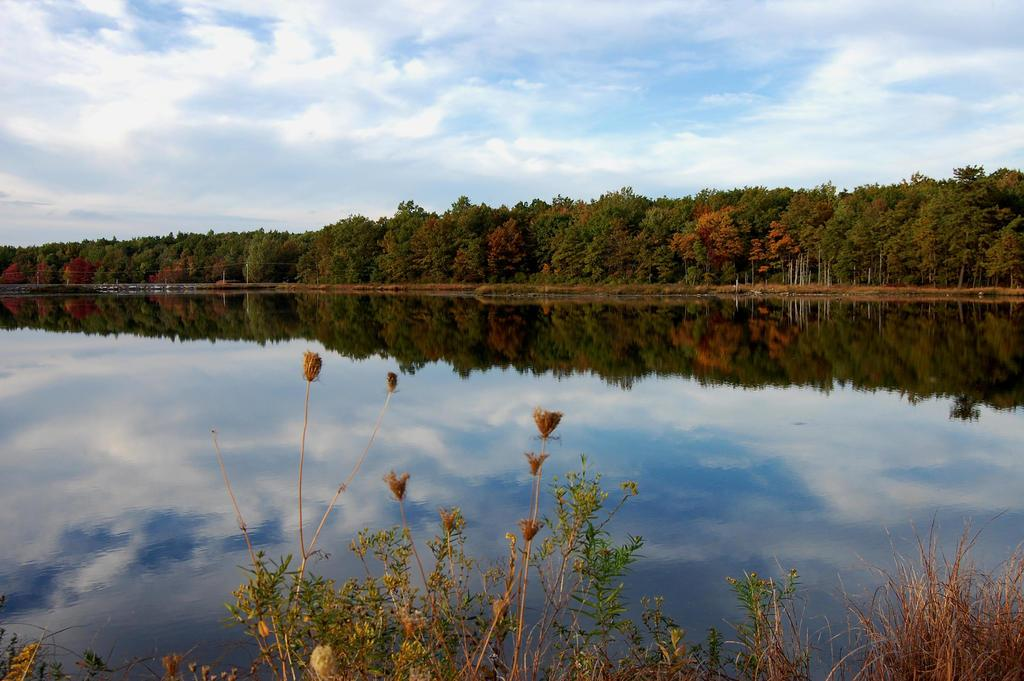What type of vegetation is present in the image? There is grass in the image. What else can be seen in the image besides grass? There is water, poles, wires, trees, and the sky visible in the image. What might be the location of the image based on the presence of water? The image might have been taken near a lake, given the presence of water. How many sheep can be seen grazing in the grass in the image? There are no sheep present in the image. What type of shock might someone experience if they touch the wires in the image? There is no information about the wires being electrified or dangerous in the image, so it is not possible to determine if someone would experience a shock. 